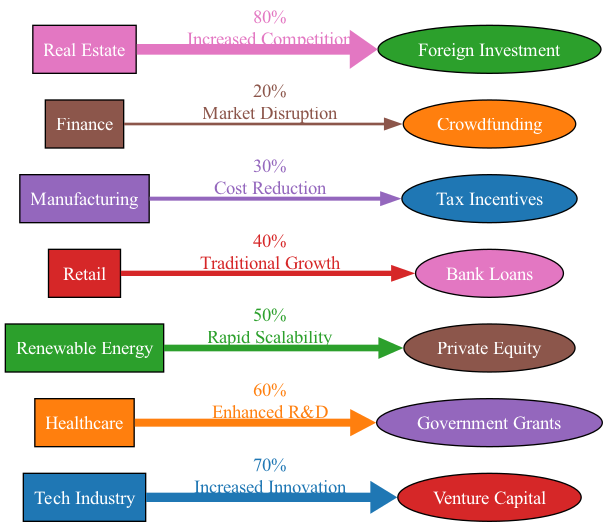What is the funding source for the Tech Industry? The diagram shows that the Tech Industry's funding source is Venture Capital, as indicated by the directed edge from the Tech Industry to Venture Capital.
Answer: Venture Capital What is the value of funding from Real Estate to Foreign Investment? The edge from Real Estate to Foreign Investment indicates a value of 80%, which is noted on the label of the connecting line in the diagram.
Answer: 80% How many sectors are represented in the diagram? To determine the number of sectors, we count the unique source nodes in the diagram, which total to 7 (Tech Industry, Healthcare, Renewable Energy, Retail, Manufacturing, Finance, Real Estate).
Answer: 7 What impact does funding from Healthcare to Government Grants have? The edge from Healthcare to Government Grants has a label indicating the impact is "Enhanced R&D." This can be found on the label of the edge that connects those two nodes.
Answer: Enhanced R&D Which sector has the lowest funding represented in the diagram? By comparing the values indicated on the edges, the Finance sector shows 20% funding from Crowdfunding, which is the smallest value among all sectors in this diagram.
Answer: Finance Which sector experiences increased competition due to foreign investment? The diagram clearly indicates that the Real Estate sector experiences "Increased Competition" as a result of the funding from Foreign Investment, shown on the edge connecting these two nodes.
Answer: Real Estate What is the impact of funding for Retail via Bank Loans? According to the label on the connecting edge from Retail to Bank Loans, the impact is described as "Traditional Growth." This is the information conveyed in the diagram.
Answer: Traditional Growth How does the value of funding from Renewable Energy compare to that of Manufacturing? The funding value for Renewable Energy is 50%, and for Manufacturing, it is 30%. Compared to each other, this means Renewable Energy has a higher value than Manufacturing.
Answer: 50% vs 30% What can be inferred about the Tech Industry's innovation due to its funding source? The edge label from Tech Industry to Venture Capital indicates an "Increased Innovation" impact, suggesting that this funding source promotes a high level of innovation in the Tech Industry.
Answer: Increased Innovation 